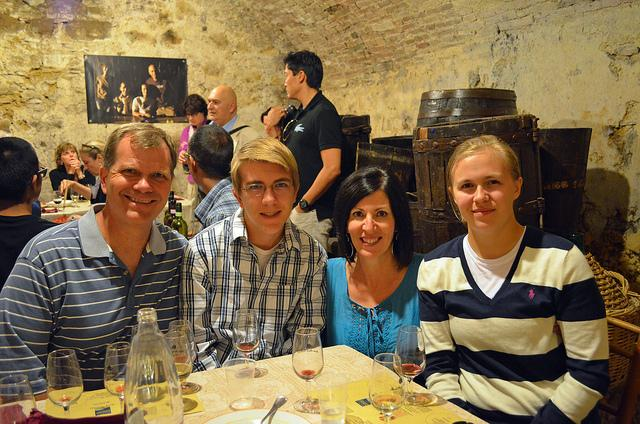What pattern is the young guy's shirt? Please explain your reasoning. plaid. The blond guy is the younger looking that the man beside him and his shirt has this type of pattern. 